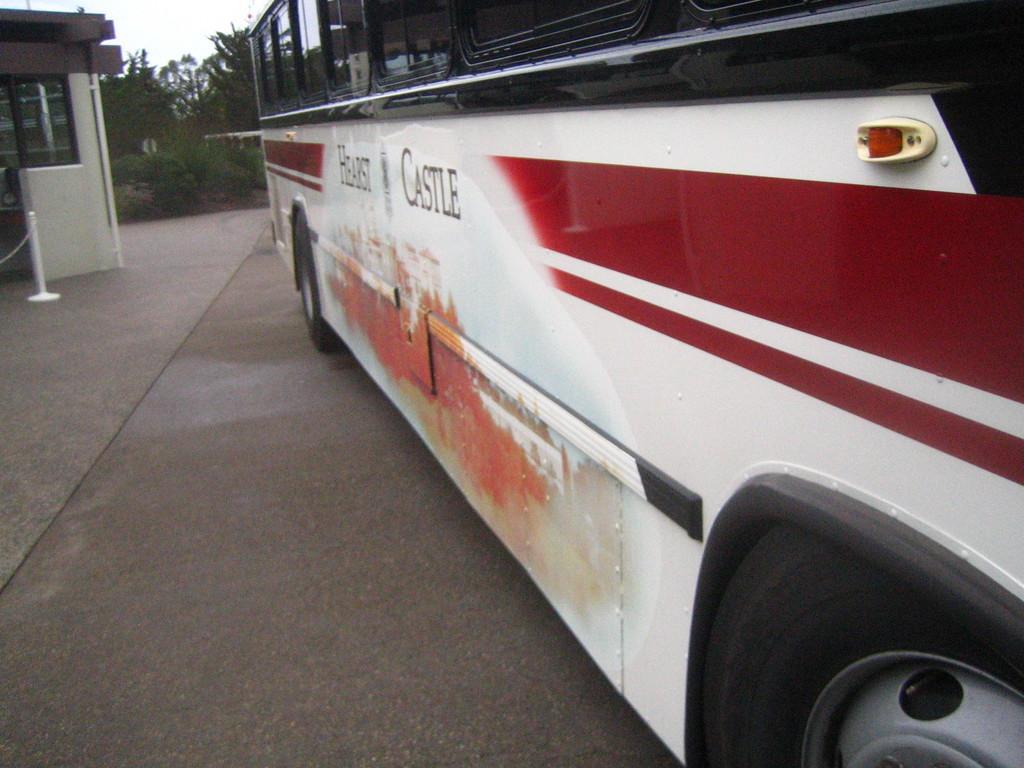How would you summarize this image in a sentence or two? In this image, at the right side we can see a bus, at the left side there is a house and there are some trees, at the top there is a sky. 